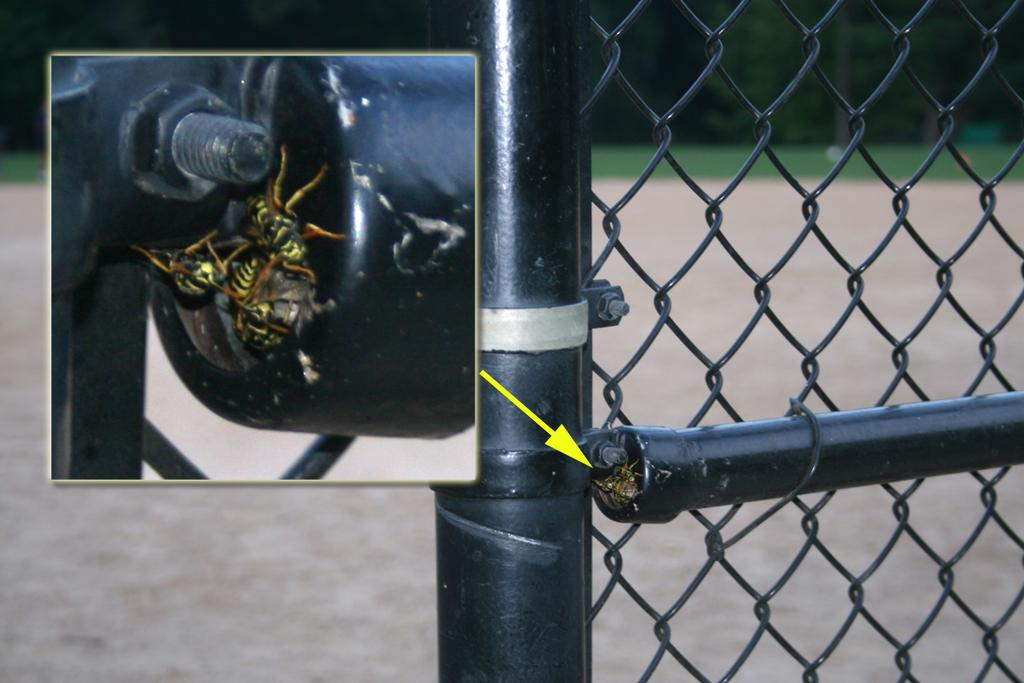What color is the fencing in the image? The fencing in the image is black-colored. Where is the fencing located in the image? The fencing is on the ground in the image. What can be seen in the background of the image? There is ground, grass, and trees visible in the background of the image. Can you tell me how many firemen are standing near the fencing in the image? There are no firemen present in the image; it only features black-colored fencing on the ground. Is there a girl playing with an appliance in the image? There is no girl or appliance present in the image. 